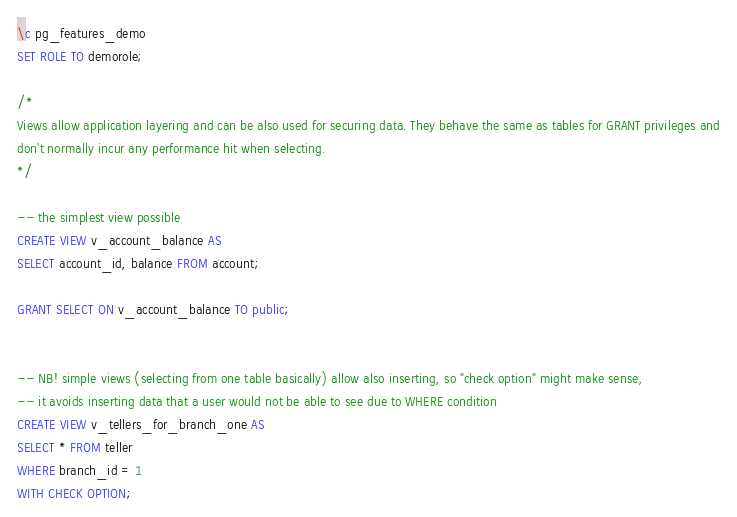Convert code to text. <code><loc_0><loc_0><loc_500><loc_500><_SQL_>\c pg_features_demo
SET ROLE TO demorole;

/*
Views allow application layering and can be also used for securing data. They behave the same as tables for GRANT privileges and
don't normally incur any performance hit when selecting.
*/

-- the simplest view possible
CREATE VIEW v_account_balance AS
SELECT account_id, balance FROM account;

GRANT SELECT ON v_account_balance TO public;


-- NB! simple views (selecting from one table basically) allow also inserting, so "check option" might make sense,
-- it avoids inserting data that a user would not be able to see due to WHERE condition
CREATE VIEW v_tellers_for_branch_one AS
SELECT * FROM teller
WHERE branch_id = 1
WITH CHECK OPTION;
</code> 